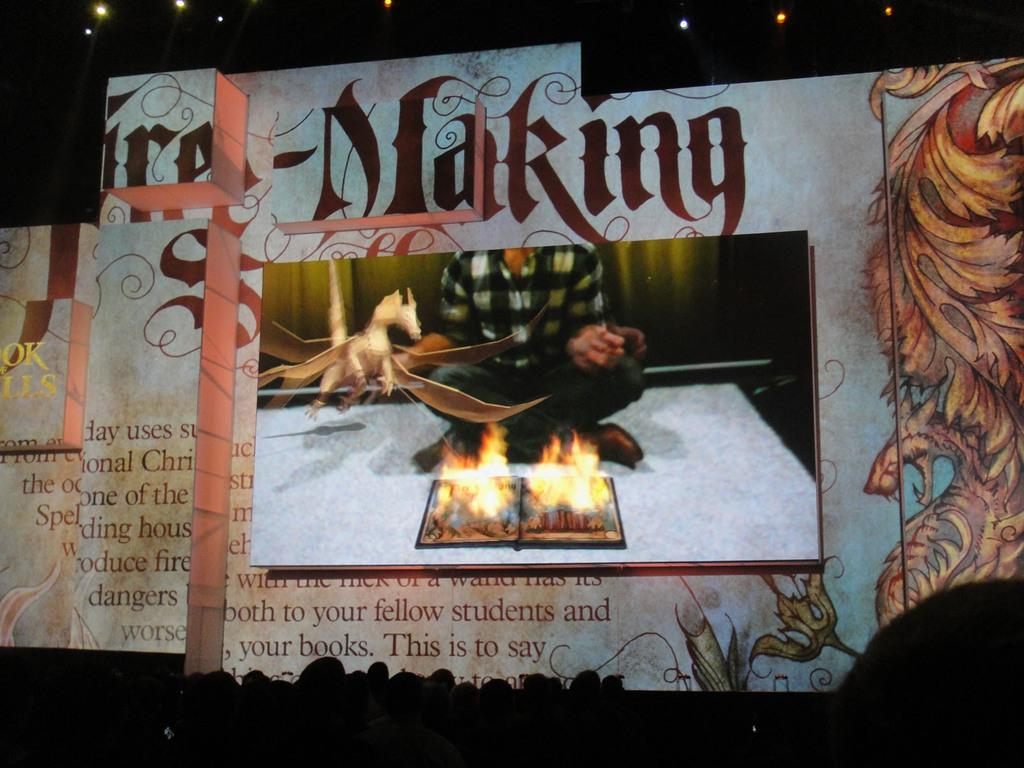What is the main object in the image? There is a screen in the image. Can you describe the background of the image? There are lights visible in the background of the image. Can you tell me how many owls are sitting on the screen in the image? There are no owls present in the image; it only features a screen and lights in the background. What angle should the screen be adjusted to in order to avoid burn-in? The provided facts do not mention any information about burn-in or adjusting the screen angle, so it cannot be answered definitively. 